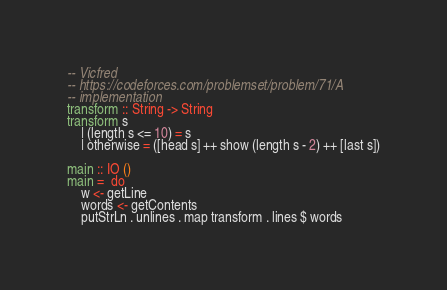<code> <loc_0><loc_0><loc_500><loc_500><_Haskell_>-- Vicfred
-- https://codeforces.com/problemset/problem/71/A
-- implementation
transform :: String -> String
transform s
    | (length s <= 10) = s
    | otherwise = ([head s] ++ show (length s - 2) ++ [last s])

main :: IO ()
main =  do
    w <- getLine
    words <- getContents
    putStrLn . unlines . map transform . lines $ words

</code> 